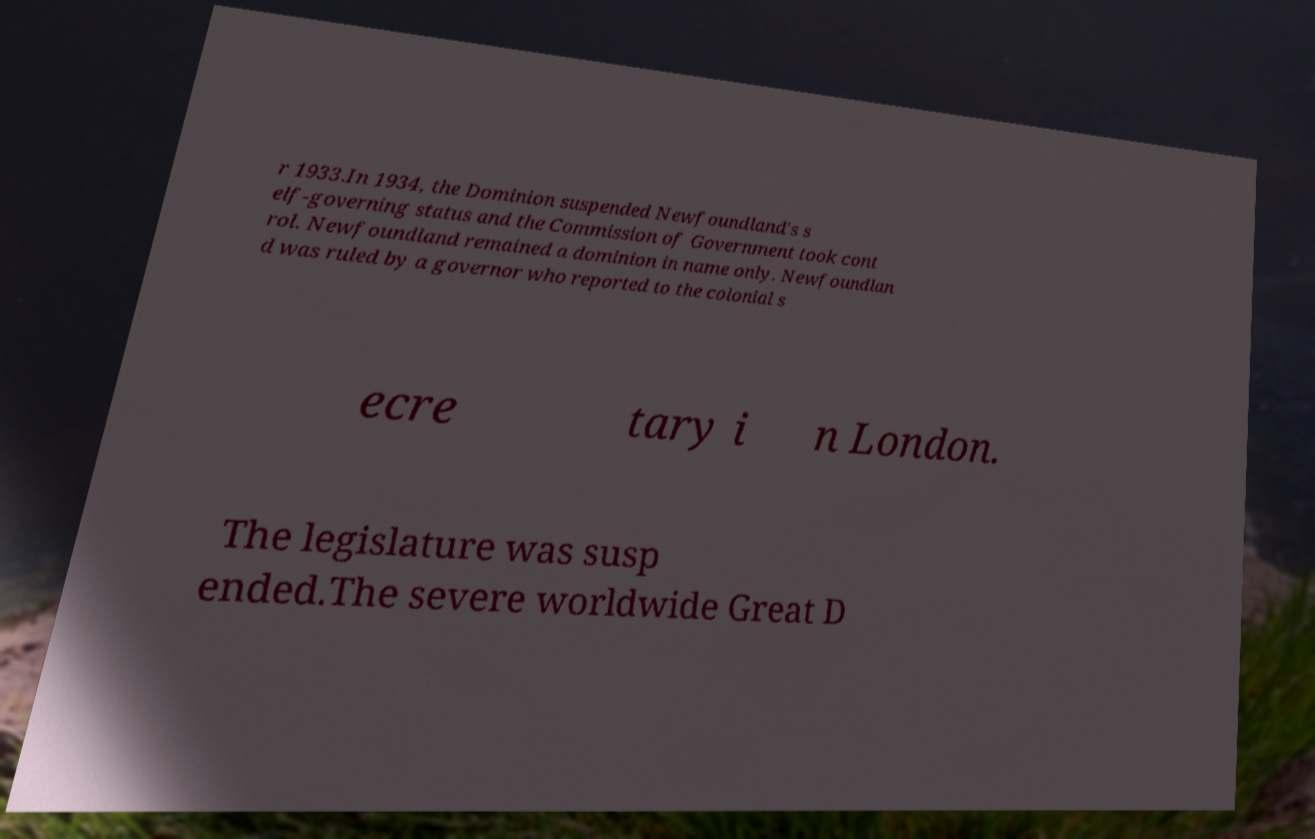What messages or text are displayed in this image? I need them in a readable, typed format. r 1933.In 1934, the Dominion suspended Newfoundland's s elf-governing status and the Commission of Government took cont rol. Newfoundland remained a dominion in name only. Newfoundlan d was ruled by a governor who reported to the colonial s ecre tary i n London. The legislature was susp ended.The severe worldwide Great D 